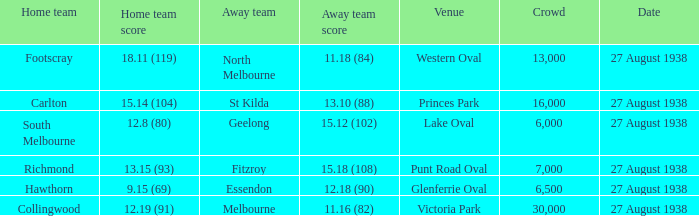Would you mind parsing the complete table? {'header': ['Home team', 'Home team score', 'Away team', 'Away team score', 'Venue', 'Crowd', 'Date'], 'rows': [['Footscray', '18.11 (119)', 'North Melbourne', '11.18 (84)', 'Western Oval', '13,000', '27 August 1938'], ['Carlton', '15.14 (104)', 'St Kilda', '13.10 (88)', 'Princes Park', '16,000', '27 August 1938'], ['South Melbourne', '12.8 (80)', 'Geelong', '15.12 (102)', 'Lake Oval', '6,000', '27 August 1938'], ['Richmond', '13.15 (93)', 'Fitzroy', '15.18 (108)', 'Punt Road Oval', '7,000', '27 August 1938'], ['Hawthorn', '9.15 (69)', 'Essendon', '12.18 (90)', 'Glenferrie Oval', '6,500', '27 August 1938'], ['Collingwood', '12.19 (91)', 'Melbourne', '11.16 (82)', 'Victoria Park', '30,000', '27 August 1938']]} Which away team scored 12.18 (90)? Essendon. 